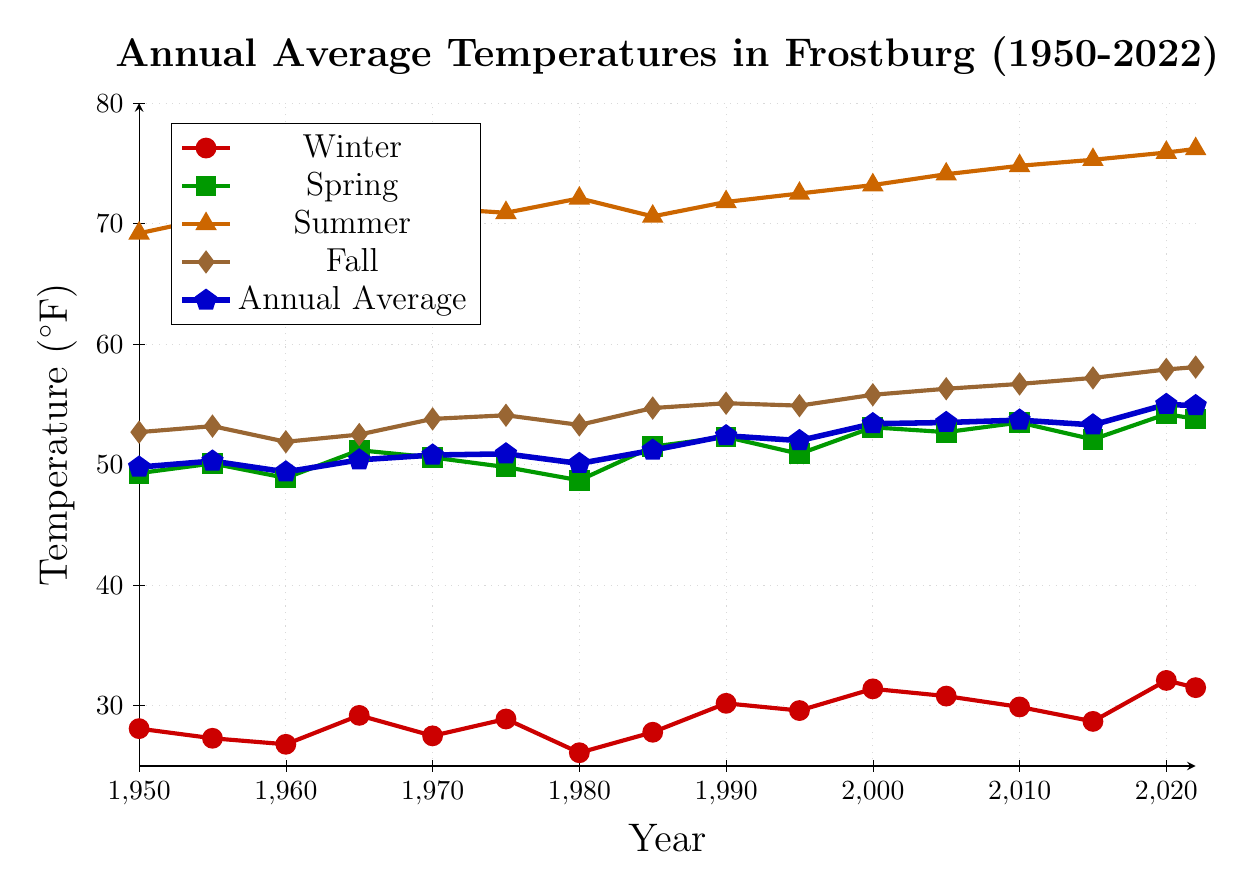Which season had the highest temperature in 2022? Look at the data points for 2022 and identify the highest temperature among the seasons. Summer had a temperature of 76.2°F.
Answer: Summer Did the winter temperature increase or decrease from 1950 to 2022? Compare the winter temperature in 1950 (28.1°F) with the winter temperature in 2022 (31.5°F). The temperature increased from 28.1°F to 31.5°F.
Answer: Increase Which year had the lowest annual average temperature? Identify the data point with the lowest annual average temperature. The lowest annual average temperature was in 1960, which was 49.4°F.
Answer: 1960 By how much did the summer temperature increase from 1950 to 2022? Subtract the summer temperature in 1950 (69.2°F) from the summer temperature in 2022 (76.2°F). The increase is 76.2°F - 69.2°F = 7.0°F.
Answer: 7.0°F What was the general trend for spring temperatures from 1950 to 2022? Observe the spring temperature data points from 1950 to 2022. The spring temperature shows a general increasing trend, from 49.3°F in 1950 to 53.8°F in 2022.
Answer: Increasing In which decade did the fall temperature first exceed 55°F? Identify the years and corresponding fall temperatures and find the first decade where the fall temperature exceeded 55°F. The fall temperature first exceeded 55°F in the 1980s (55.1°F in 1990).
Answer: 1980s Compare the annual average temperature in 2000 and 2020. Which year was warmer? Look at the annual average temperatures for 2000 (53.4°F) and 2020 (55.0°F). 2020 had a higher annual average temperature.
Answer: 2020 What was the average winter temperature between 1950 and 1965? Calculate the average of the winter temperatures for the years 1950, 1955, 1960, and 1965: (28.1 + 27.3 + 26.8 + 29.2) / 4 = 27.85°F.
Answer: 27.85°F Which year had the highest spring temperature? Identify the year with the highest spring temperature among the given data points. The highest spring temperature was in 2020, which was 54.2°F.
Answer: 2020 How much did the fall temperature change from 1990 to 2022? Subtract the fall temperature in 1990 (55.1°F) from the fall temperature in 2022 (58.1°F). The change is 58.1°F - 55.1°F = 3.0°F.
Answer: 3.0°F 